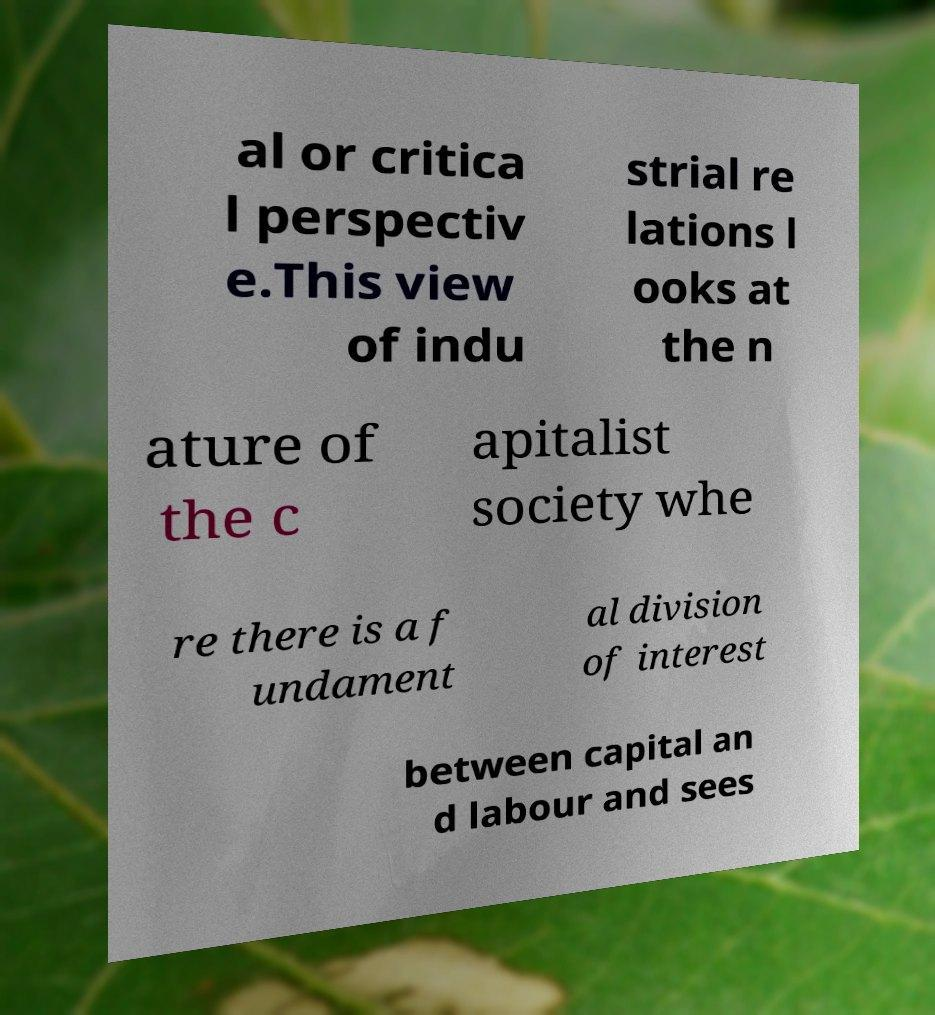What messages or text are displayed in this image? I need them in a readable, typed format. al or critica l perspectiv e.This view of indu strial re lations l ooks at the n ature of the c apitalist society whe re there is a f undament al division of interest between capital an d labour and sees 